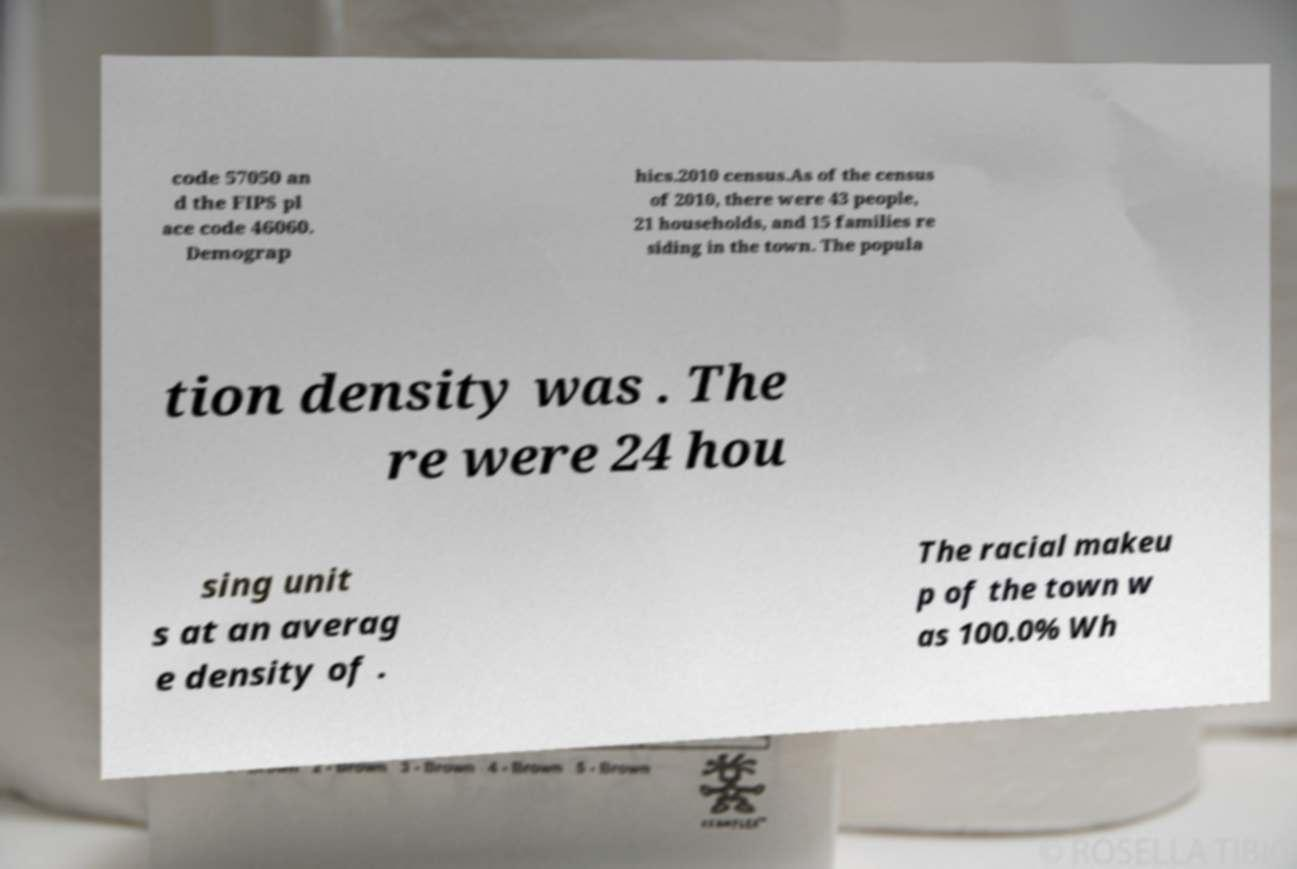Can you accurately transcribe the text from the provided image for me? code 57050 an d the FIPS pl ace code 46060. Demograp hics.2010 census.As of the census of 2010, there were 43 people, 21 households, and 15 families re siding in the town. The popula tion density was . The re were 24 hou sing unit s at an averag e density of . The racial makeu p of the town w as 100.0% Wh 